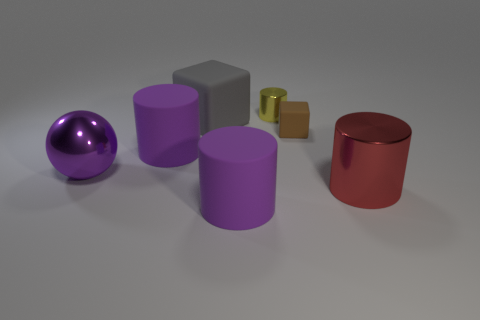Do the tiny block behind the big red object and the cylinder that is on the right side of the brown block have the same material?
Make the answer very short. No. How many things have the same material as the purple sphere?
Provide a succinct answer. 2. The big matte cube is what color?
Ensure brevity in your answer.  Gray. There is a big purple matte object behind the purple ball; does it have the same shape as the large purple object in front of the red metallic thing?
Your response must be concise. Yes. There is a big rubber object in front of the big red metal thing; what color is it?
Provide a short and direct response. Purple. Is the number of yellow shiny cylinders left of the purple metal sphere less than the number of red objects on the left side of the brown object?
Keep it short and to the point. No. How many other objects are there of the same material as the large cube?
Offer a very short reply. 3. Are the big red cylinder and the tiny brown cube made of the same material?
Offer a very short reply. No. What number of other objects are there of the same size as the gray object?
Your answer should be compact. 4. There is a metallic cylinder behind the matte cylinder left of the large gray thing; what size is it?
Make the answer very short. Small. 